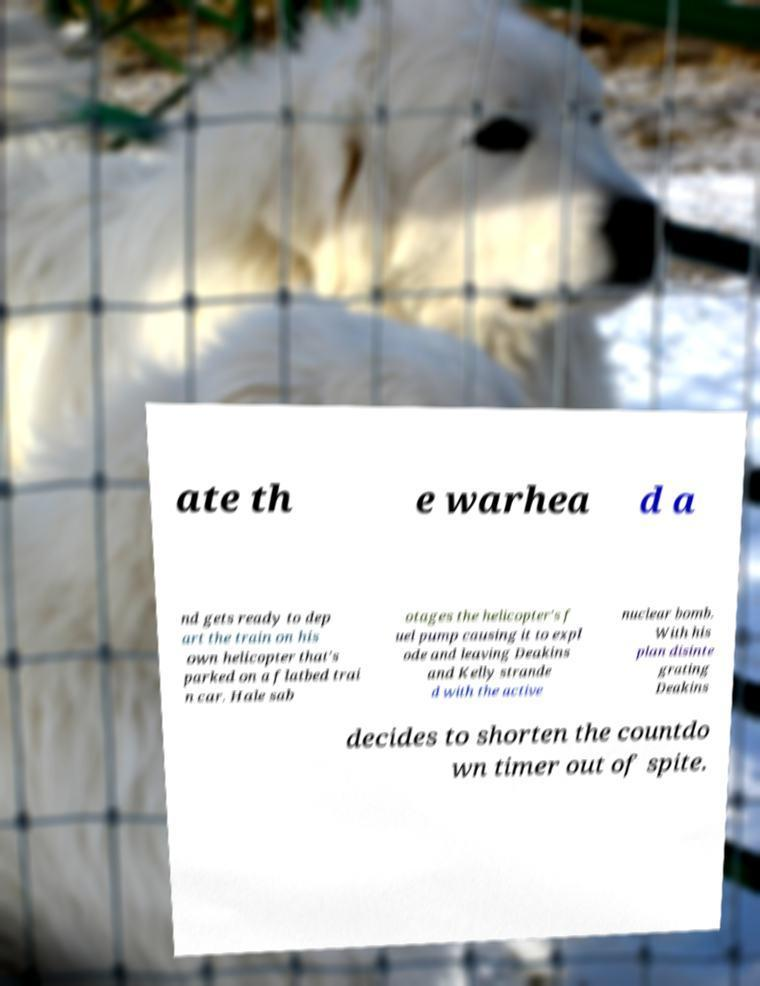Please identify and transcribe the text found in this image. ate th e warhea d a nd gets ready to dep art the train on his own helicopter that's parked on a flatbed trai n car. Hale sab otages the helicopter's f uel pump causing it to expl ode and leaving Deakins and Kelly strande d with the active nuclear bomb. With his plan disinte grating Deakins decides to shorten the countdo wn timer out of spite. 